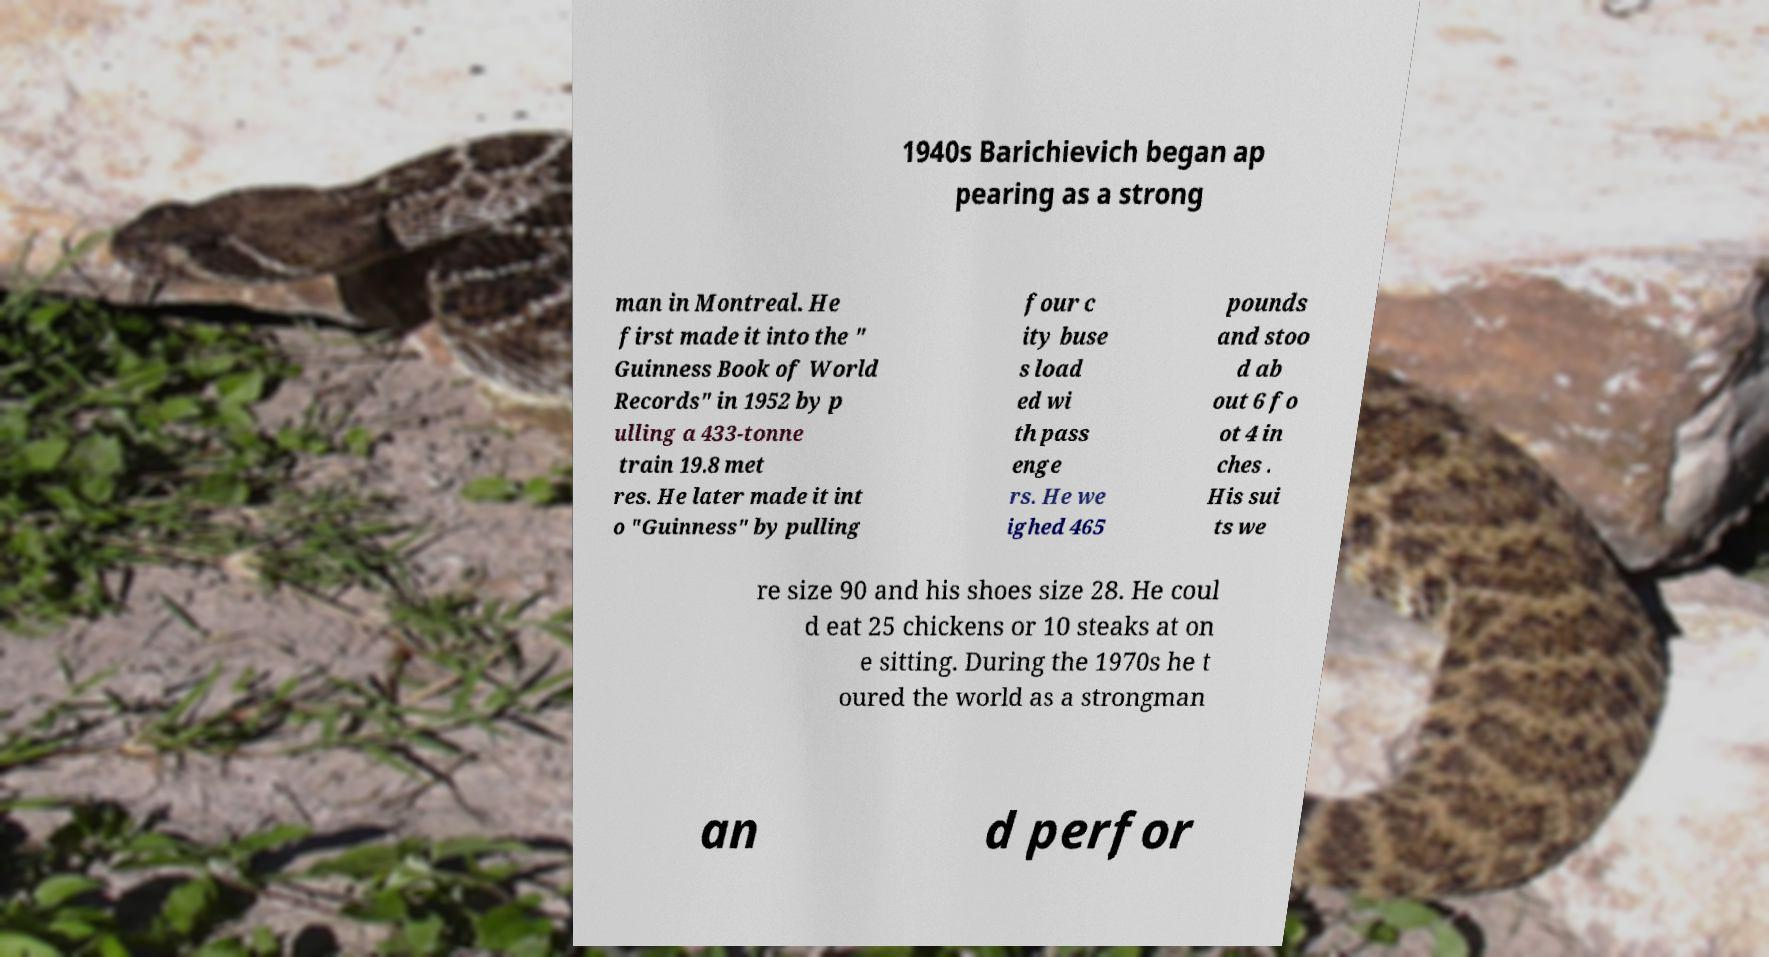Can you accurately transcribe the text from the provided image for me? 1940s Barichievich began ap pearing as a strong man in Montreal. He first made it into the " Guinness Book of World Records" in 1952 by p ulling a 433-tonne train 19.8 met res. He later made it int o "Guinness" by pulling four c ity buse s load ed wi th pass enge rs. He we ighed 465 pounds and stoo d ab out 6 fo ot 4 in ches . His sui ts we re size 90 and his shoes size 28. He coul d eat 25 chickens or 10 steaks at on e sitting. During the 1970s he t oured the world as a strongman an d perfor 